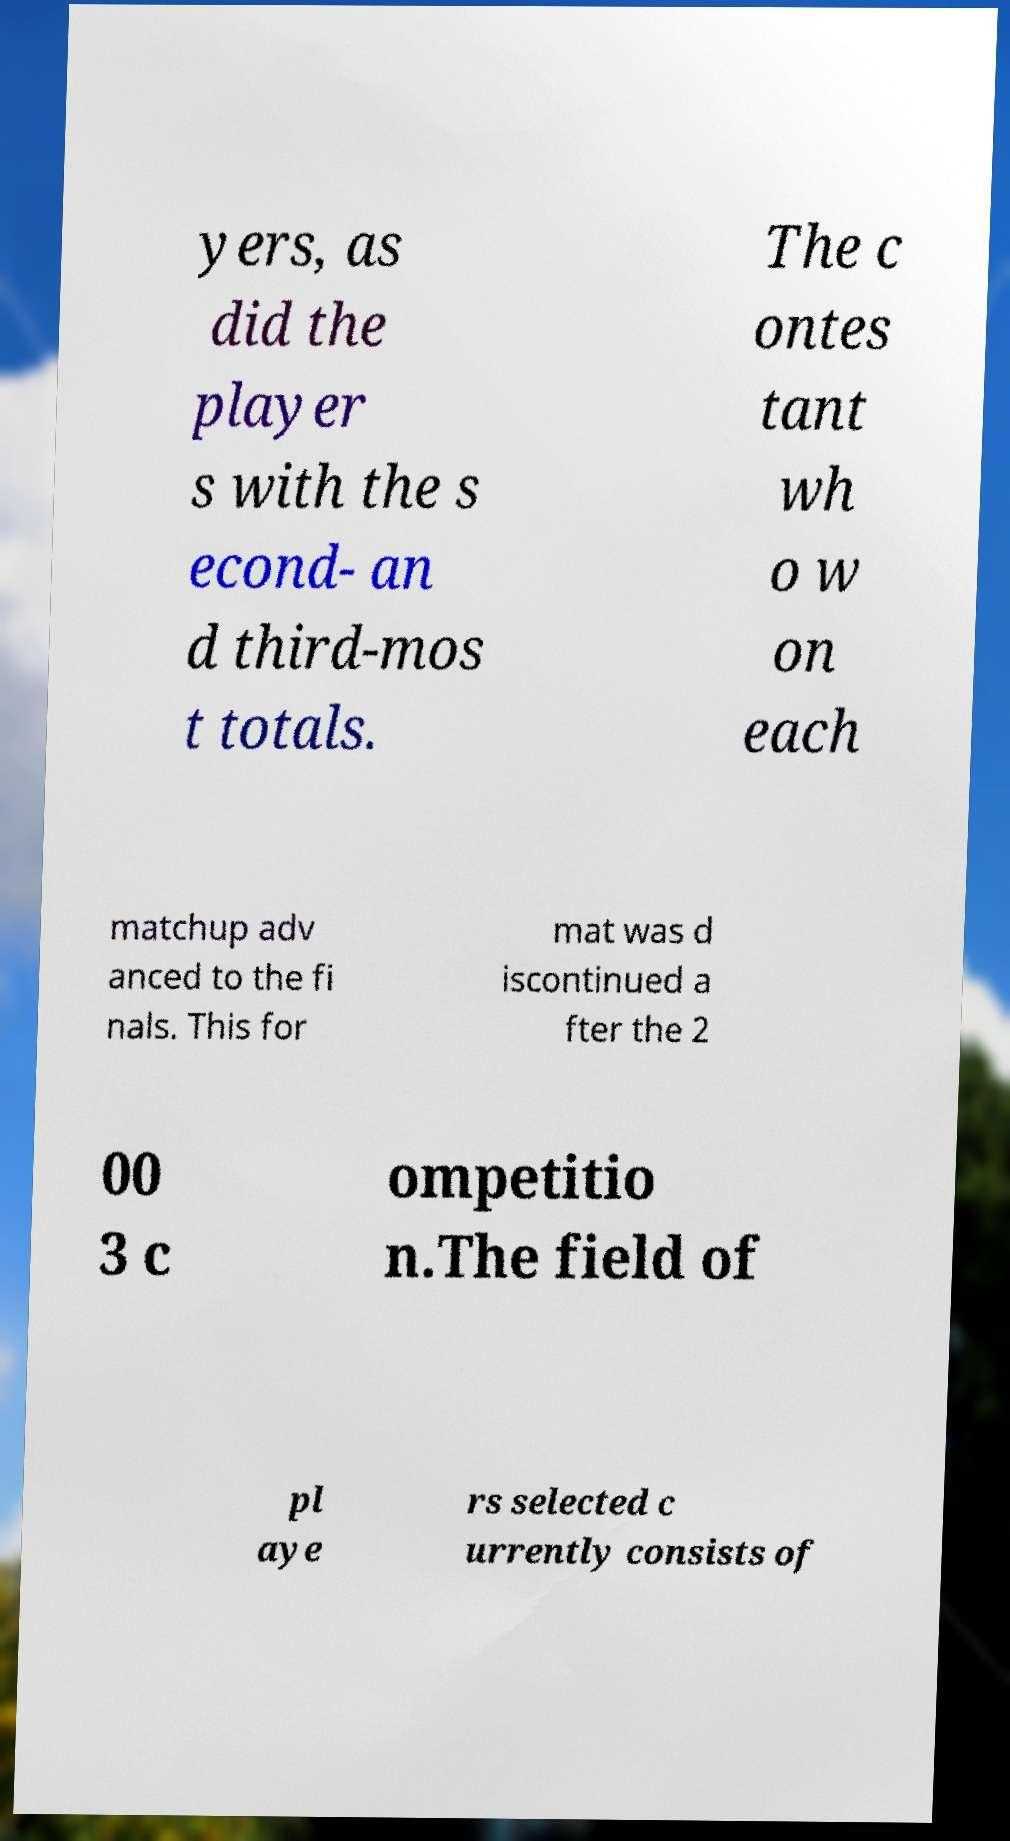I need the written content from this picture converted into text. Can you do that? yers, as did the player s with the s econd- an d third-mos t totals. The c ontes tant wh o w on each matchup adv anced to the fi nals. This for mat was d iscontinued a fter the 2 00 3 c ompetitio n.The field of pl aye rs selected c urrently consists of 